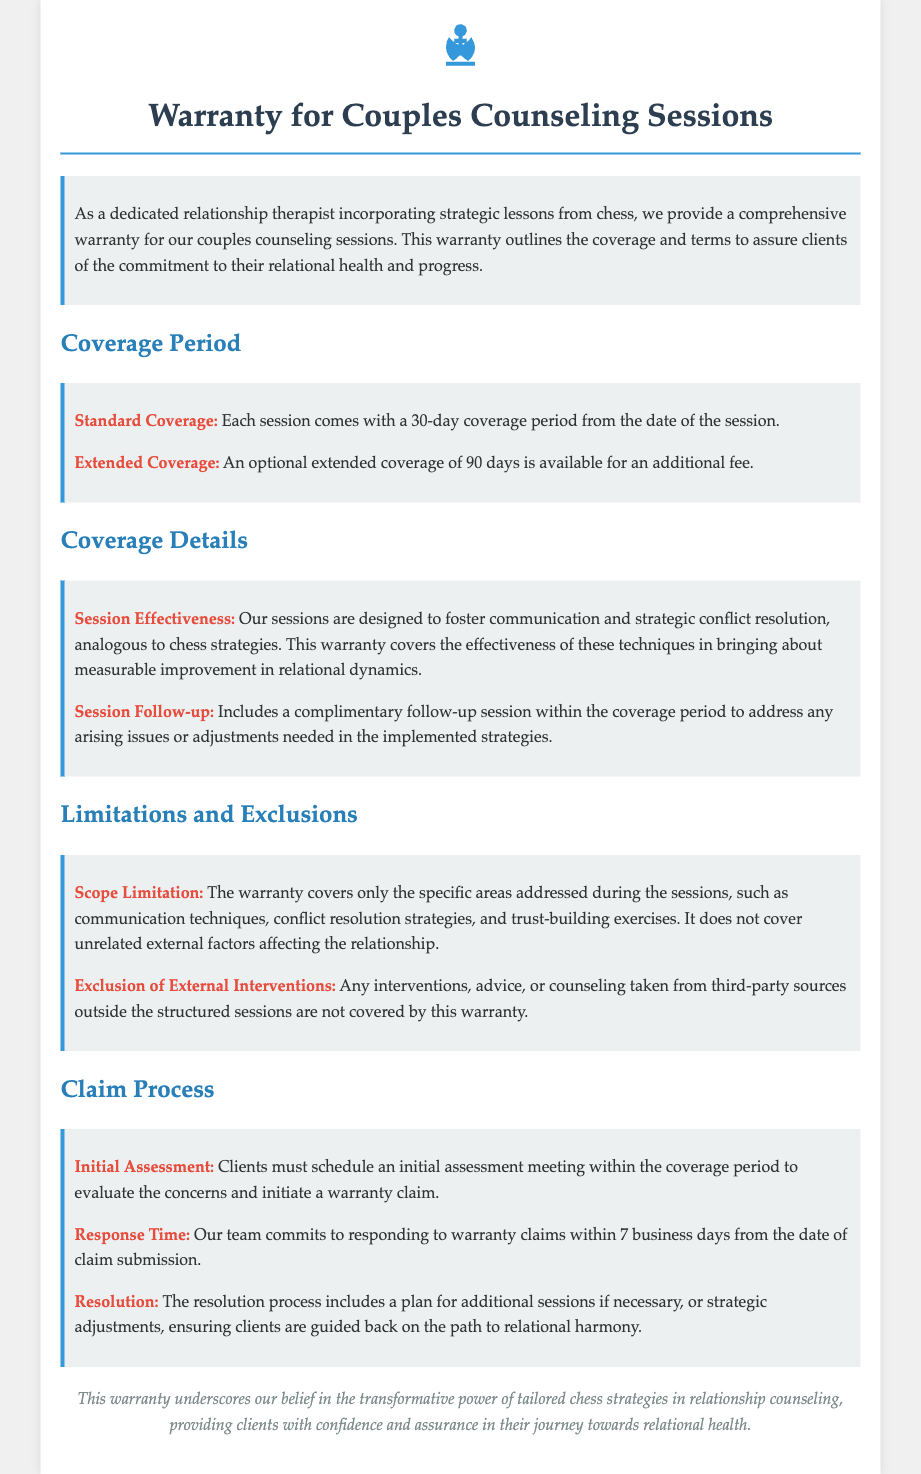What is the standard coverage period? The standard coverage period for each session is mentioned in the document as 30 days from the date of the session.
Answer: 30 days What is the extended coverage period? The document indicates that an optional extended coverage period is available for an additional fee and lasts 90 days.
Answer: 90 days What does the warranty cover regarding session effectiveness? The warranty covers the effectiveness of techniques designed to improve relational dynamics through communication and conflict resolution.
Answer: Effectiveness of techniques How long does the response time for warranty claims take? The document states that the response time for warranty claims is within 7 business days from the date of claim submission.
Answer: 7 business days What is required to initiate a warranty claim? Clients must schedule an initial assessment meeting to evaluate concerns and initiate a warranty claim as described in the document.
Answer: Initial assessment meeting What areas does the warranty exclude? The warranty excludes unrelated external factors affecting the relationship, as stated in the document.
Answer: Unrelated external factors What is included in the follow-up session? The document mentions that a complimentary follow-up session is included within the coverage period to address any arising issues.
Answer: Complimentary follow-up session What type of sessions does the warranty cover? The warranty covers sessions specifically focused on communication techniques and conflict resolution strategies.
Answer: Communication techniques and conflict resolution strategies What is the significance of this warranty? The document highlights that the warranty underscores the commitment to the relational health and progress of clients.
Answer: Commitment to relational health and progress 